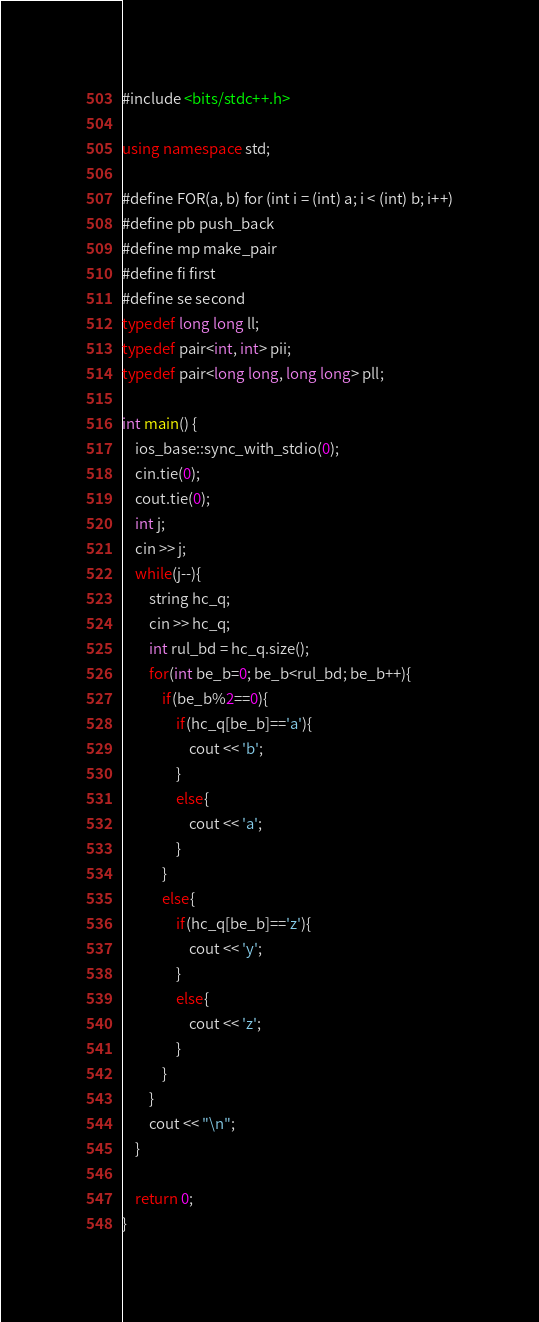Convert code to text. <code><loc_0><loc_0><loc_500><loc_500><_C++_>#include <bits/stdc++.h>

using namespace std;

#define FOR(a, b) for (int i = (int) a; i < (int) b; i++)
#define pb push_back
#define mp make_pair
#define fi first
#define se second
typedef long long ll;
typedef pair<int, int> pii;
typedef pair<long long, long long> pll;

int main() { 
    ios_base::sync_with_stdio(0);
    cin.tie(0);
    cout.tie(0);
    int j;
    cin >> j;
    while(j--){
        string hc_q;
        cin >> hc_q;
        int rul_bd = hc_q.size();
        for(int be_b=0; be_b<rul_bd; be_b++){
            if(be_b%2==0){
                if(hc_q[be_b]=='a'){
                    cout << 'b';
                }
                else{
                    cout << 'a';
                }
            }
            else{
                if(hc_q[be_b]=='z'){
                    cout << 'y';
                }
                else{
                    cout << 'z';
                }
            }
        }
        cout << "\n";
    }

    return 0;
}</code> 